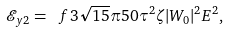Convert formula to latex. <formula><loc_0><loc_0><loc_500><loc_500>\mathcal { E } _ { y 2 } = \ f { 3 \sqrt { 1 5 } \pi } { 5 0 } \tau ^ { 2 } \zeta | W _ { 0 } | ^ { 2 } E ^ { 2 } ,</formula> 